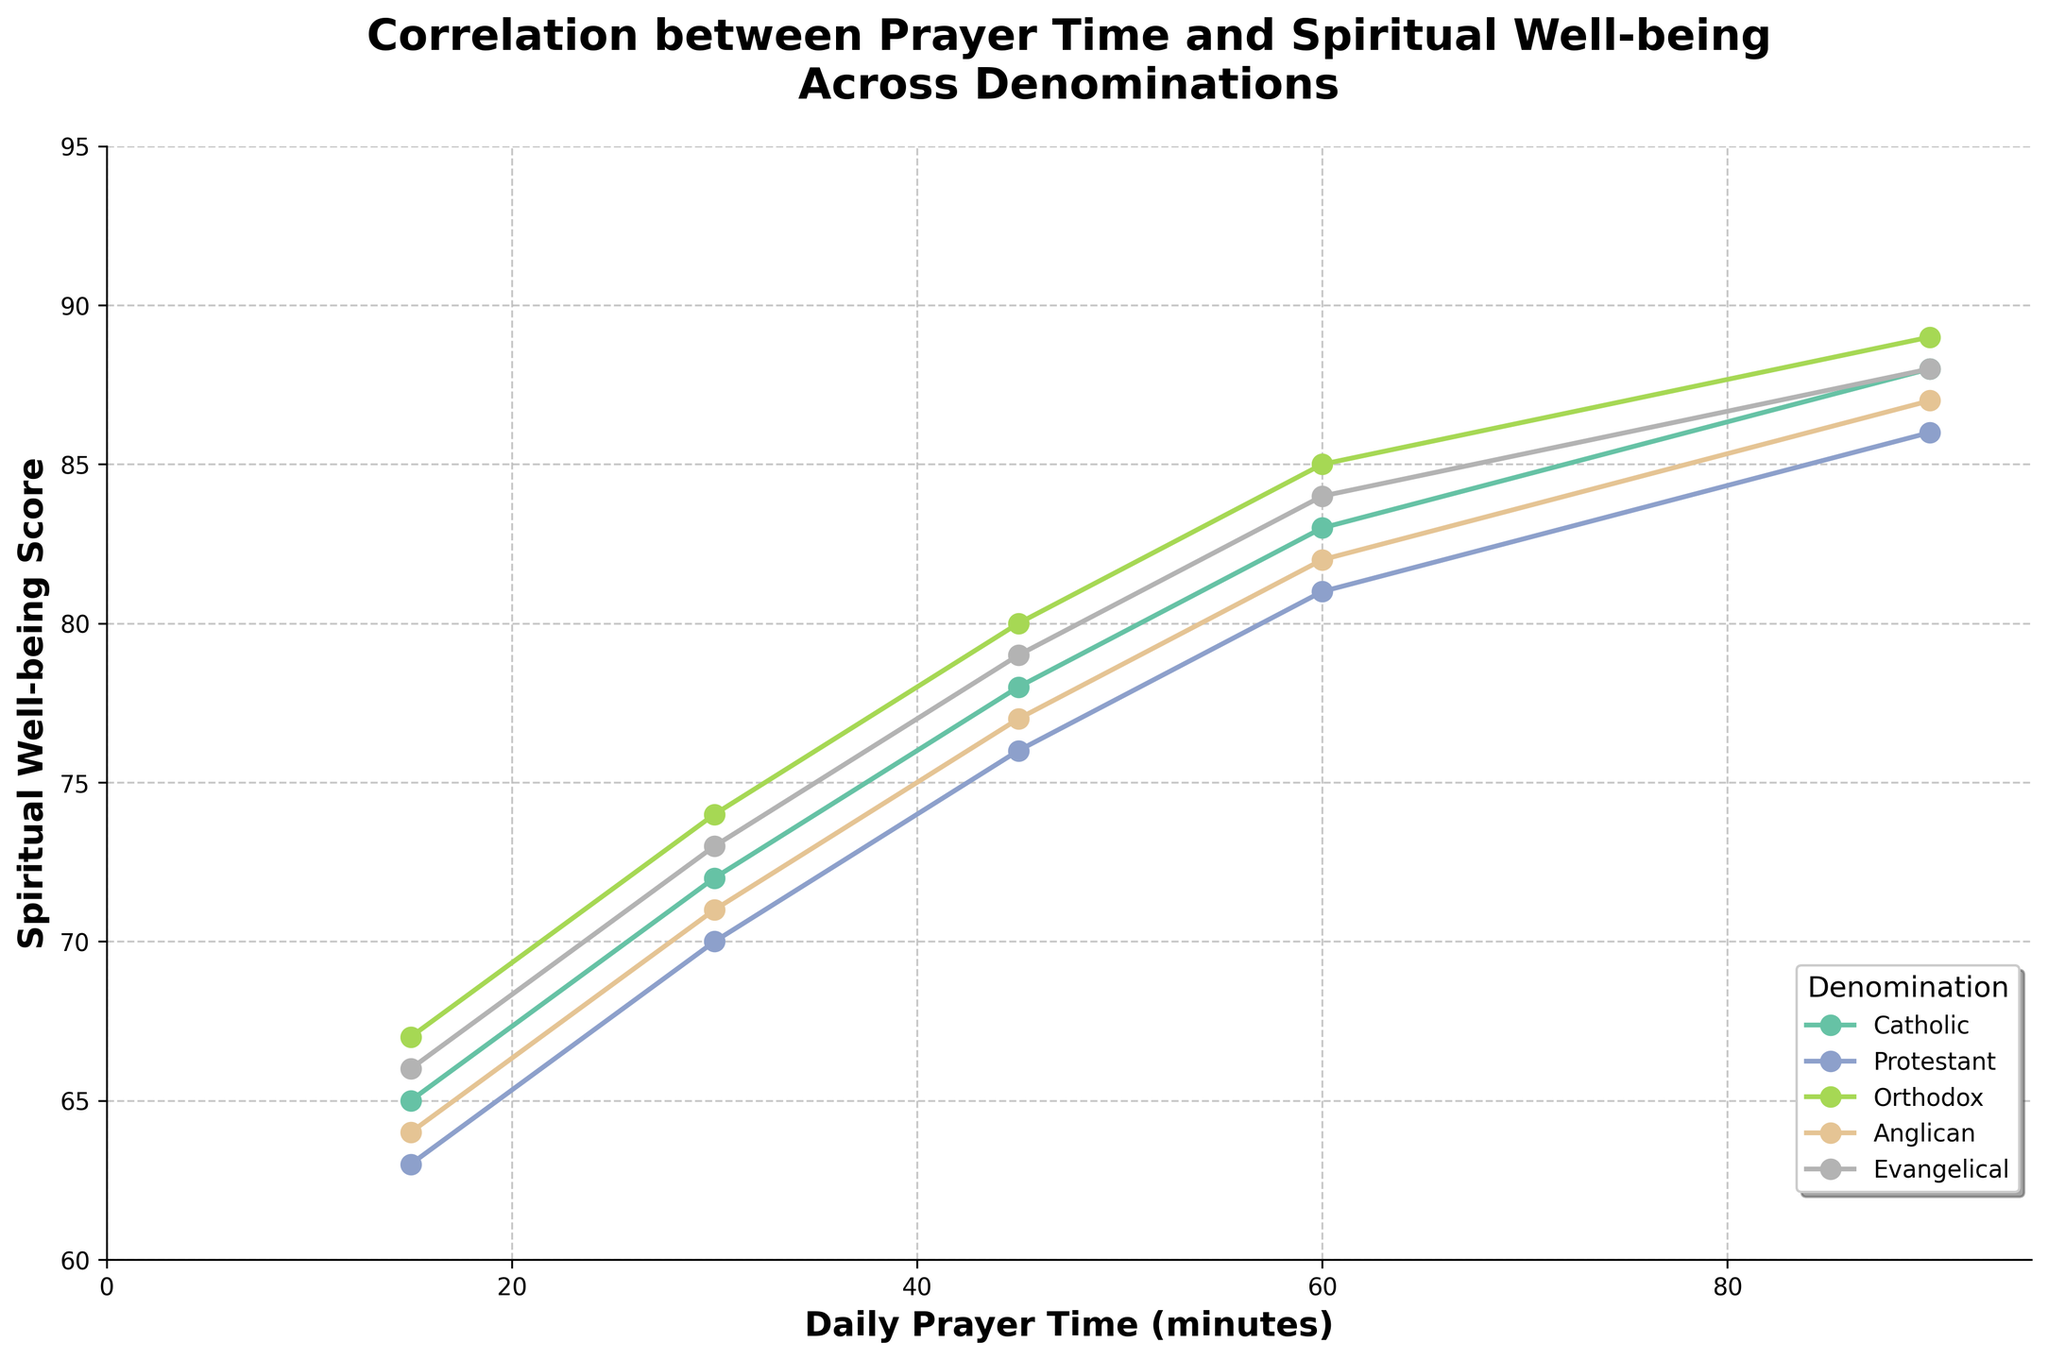How does the spiritual well-being score at 30 minutes of prayer compare across denominations? Observe the scores of each denomination at the 30-minute mark. Catholic has 72, Protestant has 70, Orthodox has 74, Anglican has 71, and Evangelical has 73.
Answer: Catholic: 72, Protestant: 70, Orthodox: 74, Anglican: 71, Evangelical: 73 Which denomination shows the highest spiritual well-being score at 60 minutes of prayer? Look at the spiritual well-being scores at the 60-minute mark for each denomination. Catholic is 83, Protestant is 81, Orthodox is 85, Anglican is 82, and Evangelical is 84.
Answer: Orthodox Between which two denominations is the difference in spiritual well-being score the smallest at 45 minutes of prayer? Look at the scores at 45 minutes for each denomination. Catholic is 78, Protestant is 76, Orthodox is 80, Anglican is 77, and Evangelical is 79. Calculate the differences: Catholic-Protestant: 2, Catholic-Orthodox: 2, Catholic-Anglican: 1, Catholic-Evangelical: 1, Protestant-Orthodox: 4, Protestant-Anglican: 1, Protestant-Evangelical: 3, Orthodox-Anglican: 3, Orthodox-Evangelical: 1, Anglican-Evangelical: 2.
Answer: Catholic-Anglican and Catholic-Evangelical (both 1) What is the average spiritual well-being score for the Evangelical denomination across all prayer times? Sum the scores for the Evangelical denomination at all prayer times: 66 + 73 + 79 + 84 + 88. The total is 390. Divide by the number of data points, which is 5.
Answer: 78 Which denomination has the steepest rate of increase in spiritual well-being score from 15 minutes to 90 minutes of prayer? Calculate the rate of increase for each denomination from 15 minutes to 90 minutes: Catholic: (88-65)/(90-15) = 23/75 = 0.3067, Protestant: (86-63)/(90-15) = 23/75 = 0.3067, Orthodox: (89-67)/(90-15) = 22/75 = 0.2933, Anglican: (87-64)/(90-15) = 23/75 = 0.3067, Evangelical: (88-66)/(90-15) = 22/75 = 0.2933.
Answer: Catholic, Protestant, and Anglican (all 0.3067) How does the spiritual well-being score for the Orthodox denomination at 45 minutes compare to that of the Evangelical denomination at 90 minutes? Look at the scores for the Orthodox denomination at 45 minutes (80) and for the Evangelical denomination at 90 minutes (88).
Answer: Orthodox: 80, Evangelical: 88 Which denomination shows the most consistent increase in spiritual well-being with increased prayer time? Examine the graph to see which denomination has the most linear or consistently spaced points.
Answer: Evangelical What is the range of spiritual well-being scores for the Catholic denomination? Subtract the lowest score (65) from the highest score (88) for the Catholic denomination.
Answer: 23 At 90 minutes of prayer, which two denominations have the closest spiritual well-being scores? Look at the scores at the 90-minute mark: Catholic is 88, Protestant is 86, Orthodox is 89, Anglican is 87, and Evangelical is 88. Compare the differences: Catholic-Protestant: 2, Catholic-Orthodox: 1, Catholic-Anglican: 1, Catholic-Evangelical: 0, Protestant-Orthodox: 3, Protestant-Anglican: 1, Protestant-Evangelical: 2, Orthodox-Anglican: 2, Orthodox-Evangelical: 1, Anglican-Evangelical: 1.
Answer: Catholic and Evangelical What is the cumulative difference in spiritual well-being scores between the Catholic and Protestant denominations across all prayer times? Calculate the score difference at each prayer time and sum them: 65-63=2, 72-70=2, 78-76=2, 83-81=2, 88-86=2. The total difference is 2+2+2+2+2.
Answer: 10 